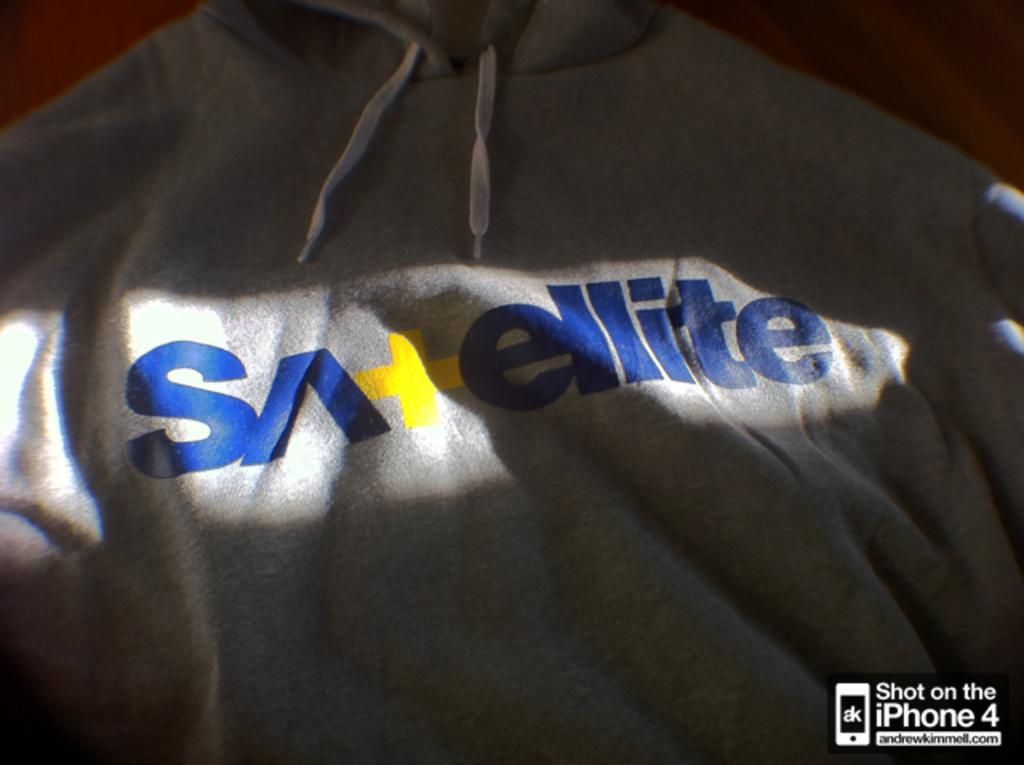<image>
Write a terse but informative summary of the picture. A hoodie that has sunlight shining on the word Satellite on it 